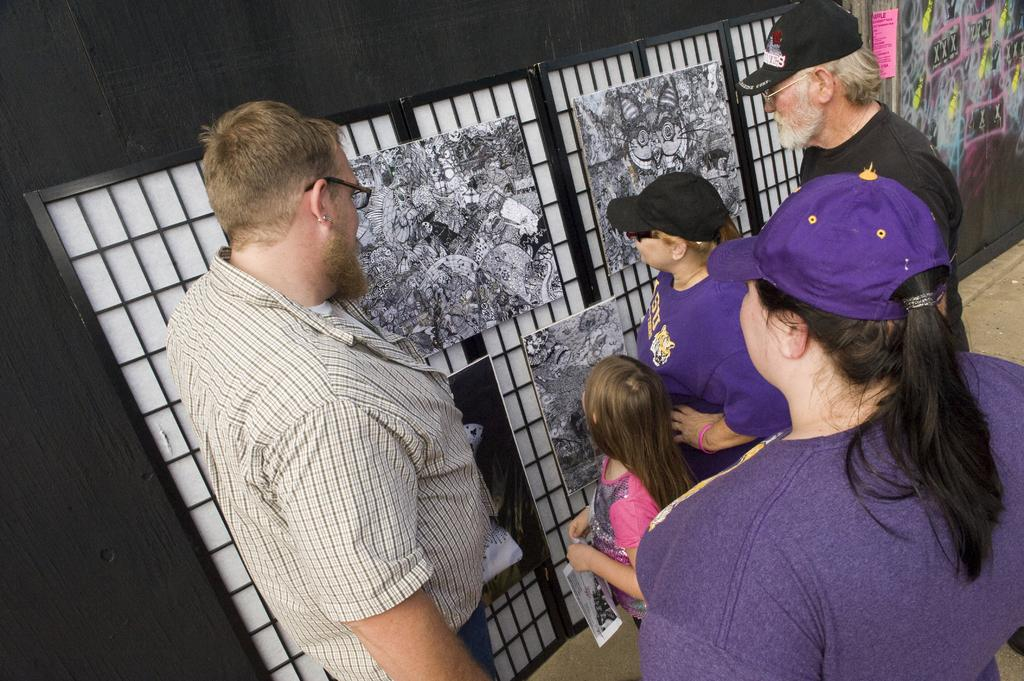Who or what can be seen in the image? There are people in the image. Where are the people located in the image? The people are standing on the right side of the image. What is in front of the people in the image? There are portraits in front of the people. How many bits can be seen in the image? There are no bits present in the image. What type of finger is visible in the image? There are no fingers visible in the image. 